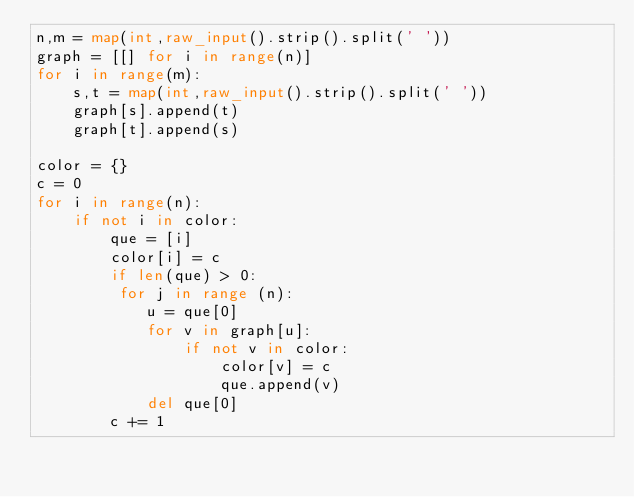Convert code to text. <code><loc_0><loc_0><loc_500><loc_500><_Python_>n,m = map(int,raw_input().strip().split(' '))
graph = [[] for i in range(n)]
for i in range(m):
    s,t = map(int,raw_input().strip().split(' '))
    graph[s].append(t)
    graph[t].append(s)
 
color = {}
c = 0
for i in range(n):
    if not i in color:
        que = [i]
        color[i] = c
        if len(que) > 0:
         for j in range (n):
            u = que[0]
            for v in graph[u]:
                if not v in color:
                    color[v] = c
                    que.append(v)
            del que[0]
        c += 1</code> 